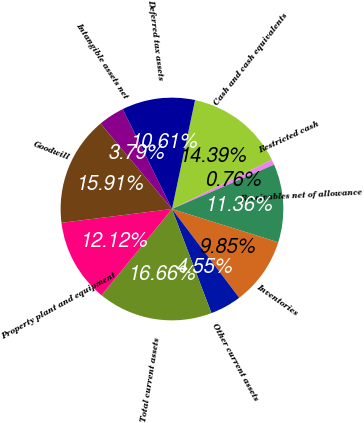Convert chart. <chart><loc_0><loc_0><loc_500><loc_500><pie_chart><fcel>Cash and cash equivalents<fcel>Restricted cash<fcel>Receivables net of allowance<fcel>Inventories<fcel>Other current assets<fcel>Total current assets<fcel>Property plant and equipment<fcel>Goodwill<fcel>Intangible assets net<fcel>Deferred tax assets<nl><fcel>14.39%<fcel>0.76%<fcel>11.36%<fcel>9.85%<fcel>4.55%<fcel>16.66%<fcel>12.12%<fcel>15.91%<fcel>3.79%<fcel>10.61%<nl></chart> 